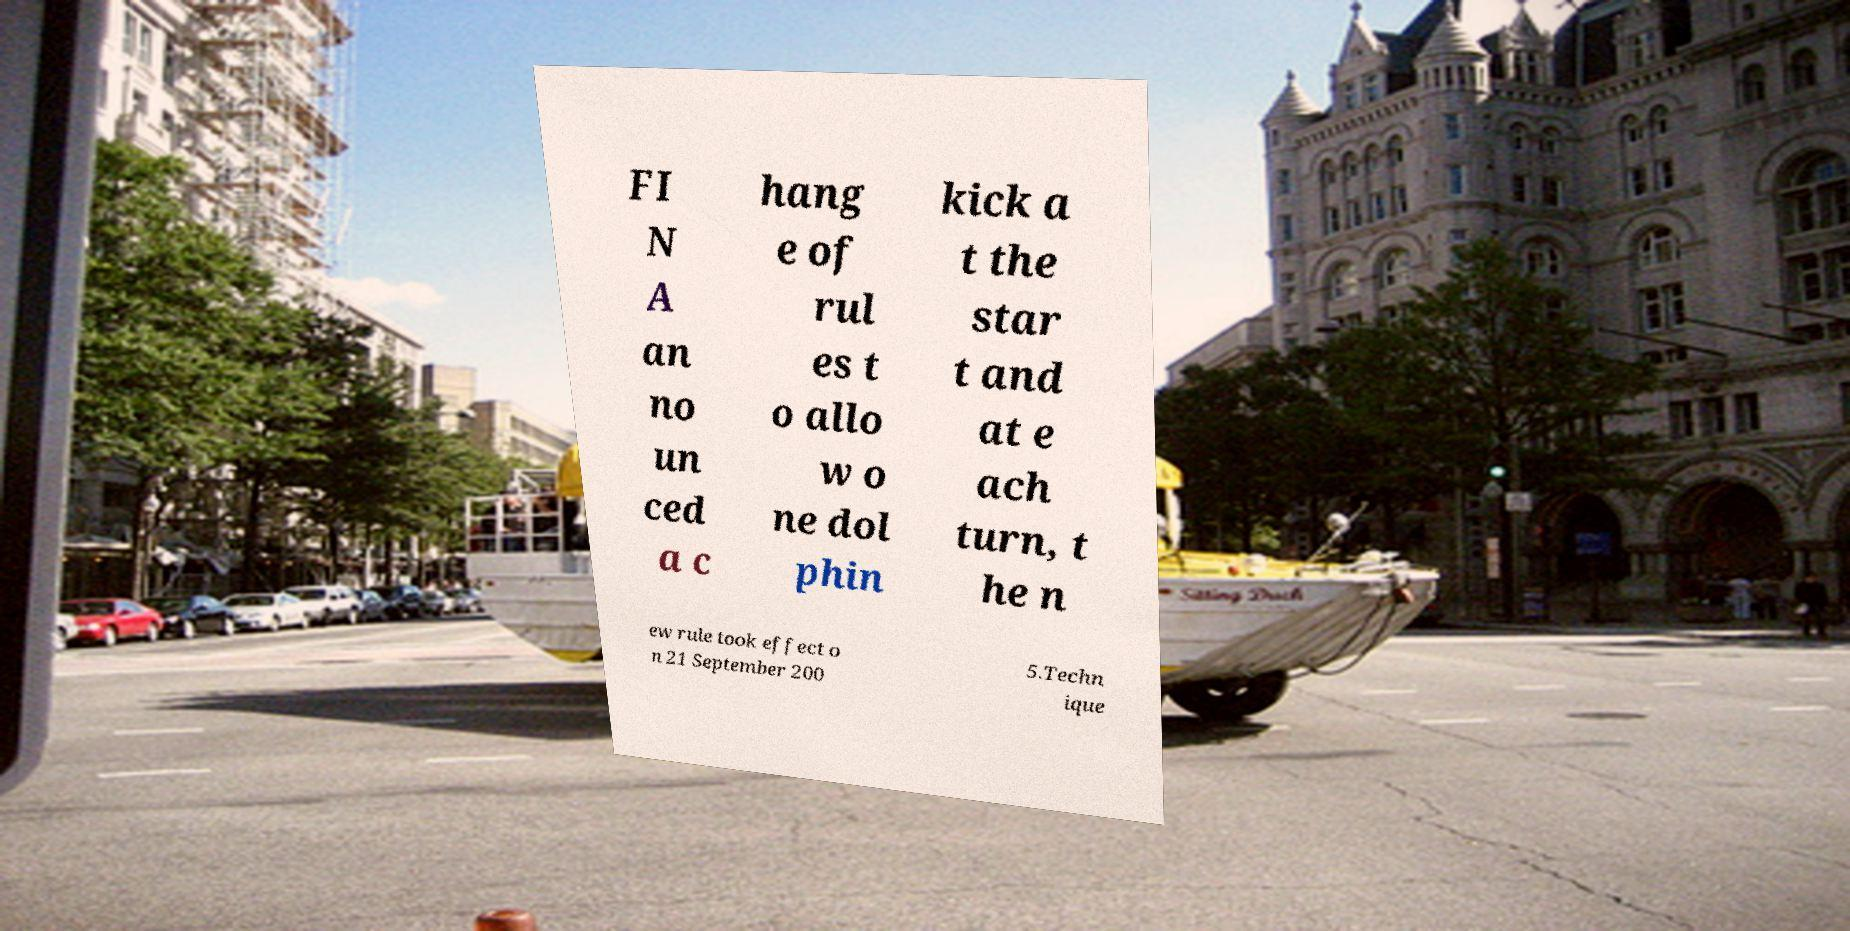There's text embedded in this image that I need extracted. Can you transcribe it verbatim? FI N A an no un ced a c hang e of rul es t o allo w o ne dol phin kick a t the star t and at e ach turn, t he n ew rule took effect o n 21 September 200 5.Techn ique 